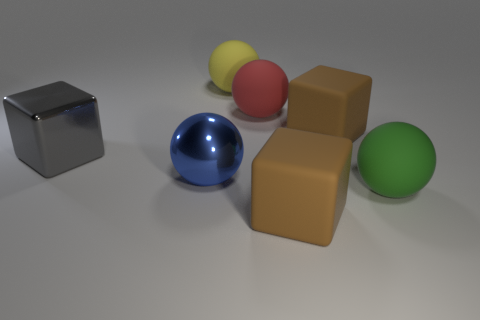Do the shiny object that is left of the blue thing and the yellow object have the same shape? no 